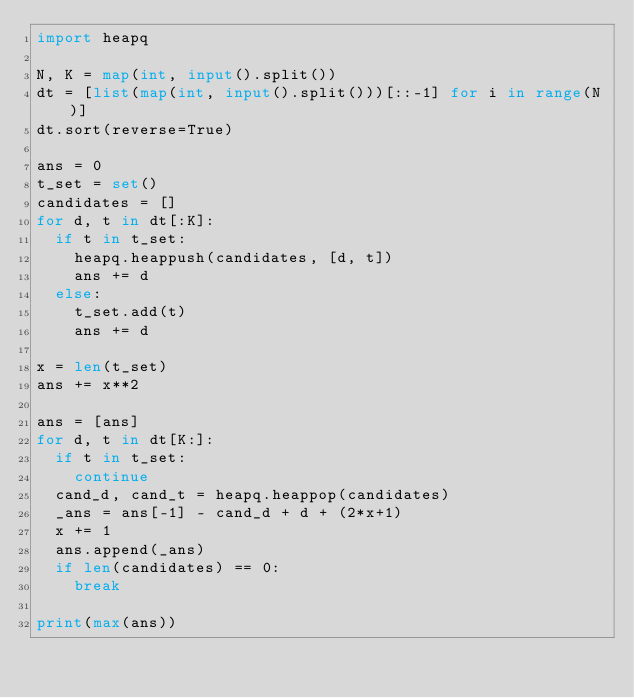Convert code to text. <code><loc_0><loc_0><loc_500><loc_500><_Python_>import heapq

N, K = map(int, input().split())
dt = [list(map(int, input().split()))[::-1] for i in range(N)]
dt.sort(reverse=True)

ans = 0
t_set = set()
candidates = []
for d, t in dt[:K]:
  if t in t_set:
    heapq.heappush(candidates, [d, t])
    ans += d
  else:
    t_set.add(t)
    ans += d

x = len(t_set)
ans += x**2

ans = [ans]
for d, t in dt[K:]:
  if t in t_set:
    continue
  cand_d, cand_t = heapq.heappop(candidates)
  _ans = ans[-1] - cand_d + d + (2*x+1)
  x += 1
  ans.append(_ans)
  if len(candidates) == 0:
    break

print(max(ans))</code> 